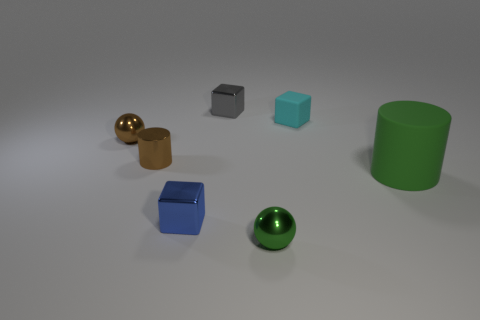Subtract all blue cylinders. Subtract all cyan spheres. How many cylinders are left? 2 Add 2 tiny brown balls. How many objects exist? 9 Subtract all cubes. How many objects are left? 4 Add 3 small cyan rubber objects. How many small cyan rubber objects are left? 4 Add 1 green spheres. How many green spheres exist? 2 Subtract 1 cyan cubes. How many objects are left? 6 Subtract all red things. Subtract all tiny cyan blocks. How many objects are left? 6 